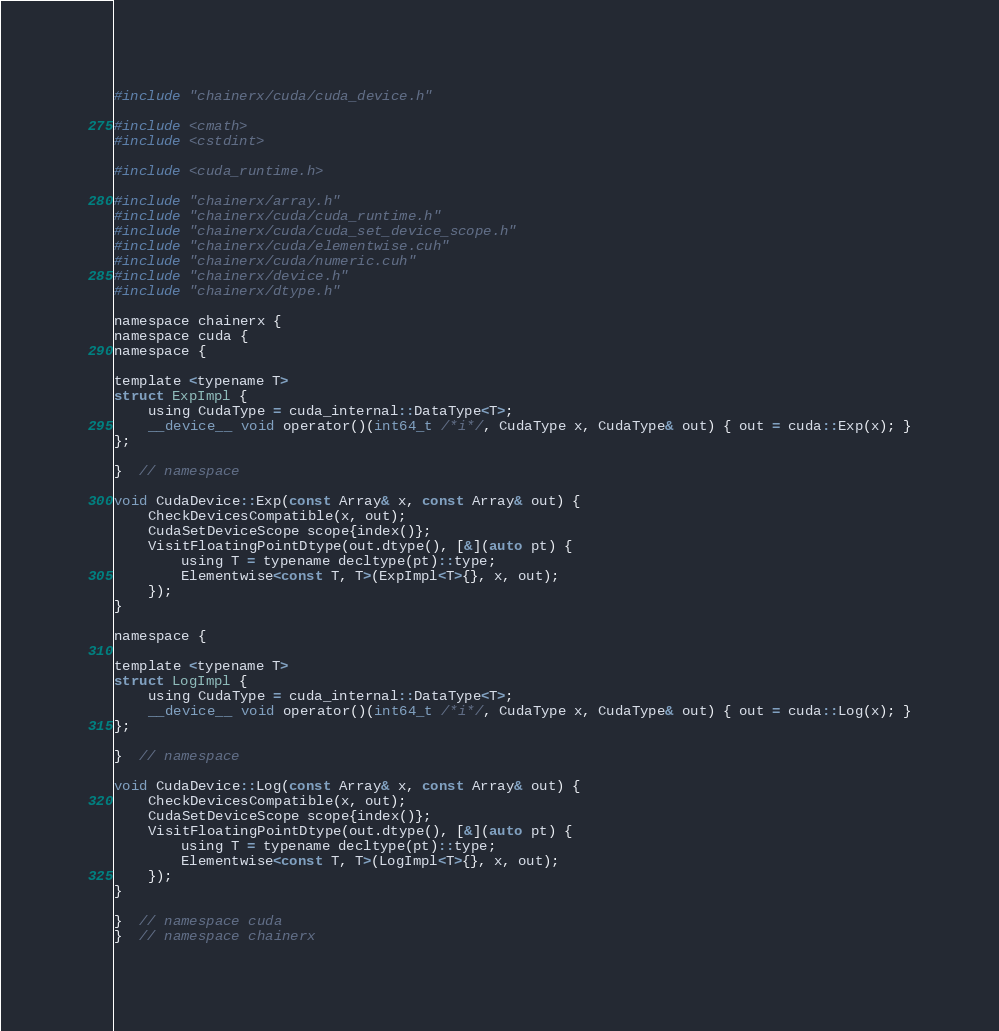<code> <loc_0><loc_0><loc_500><loc_500><_Cuda_>#include "chainerx/cuda/cuda_device.h"

#include <cmath>
#include <cstdint>

#include <cuda_runtime.h>

#include "chainerx/array.h"
#include "chainerx/cuda/cuda_runtime.h"
#include "chainerx/cuda/cuda_set_device_scope.h"
#include "chainerx/cuda/elementwise.cuh"
#include "chainerx/cuda/numeric.cuh"
#include "chainerx/device.h"
#include "chainerx/dtype.h"

namespace chainerx {
namespace cuda {
namespace {

template <typename T>
struct ExpImpl {
    using CudaType = cuda_internal::DataType<T>;
    __device__ void operator()(int64_t /*i*/, CudaType x, CudaType& out) { out = cuda::Exp(x); }
};

}  // namespace

void CudaDevice::Exp(const Array& x, const Array& out) {
    CheckDevicesCompatible(x, out);
    CudaSetDeviceScope scope{index()};
    VisitFloatingPointDtype(out.dtype(), [&](auto pt) {
        using T = typename decltype(pt)::type;
        Elementwise<const T, T>(ExpImpl<T>{}, x, out);
    });
}

namespace {

template <typename T>
struct LogImpl {
    using CudaType = cuda_internal::DataType<T>;
    __device__ void operator()(int64_t /*i*/, CudaType x, CudaType& out) { out = cuda::Log(x); }
};

}  // namespace

void CudaDevice::Log(const Array& x, const Array& out) {
    CheckDevicesCompatible(x, out);
    CudaSetDeviceScope scope{index()};
    VisitFloatingPointDtype(out.dtype(), [&](auto pt) {
        using T = typename decltype(pt)::type;
        Elementwise<const T, T>(LogImpl<T>{}, x, out);
    });
}

}  // namespace cuda
}  // namespace chainerx
</code> 